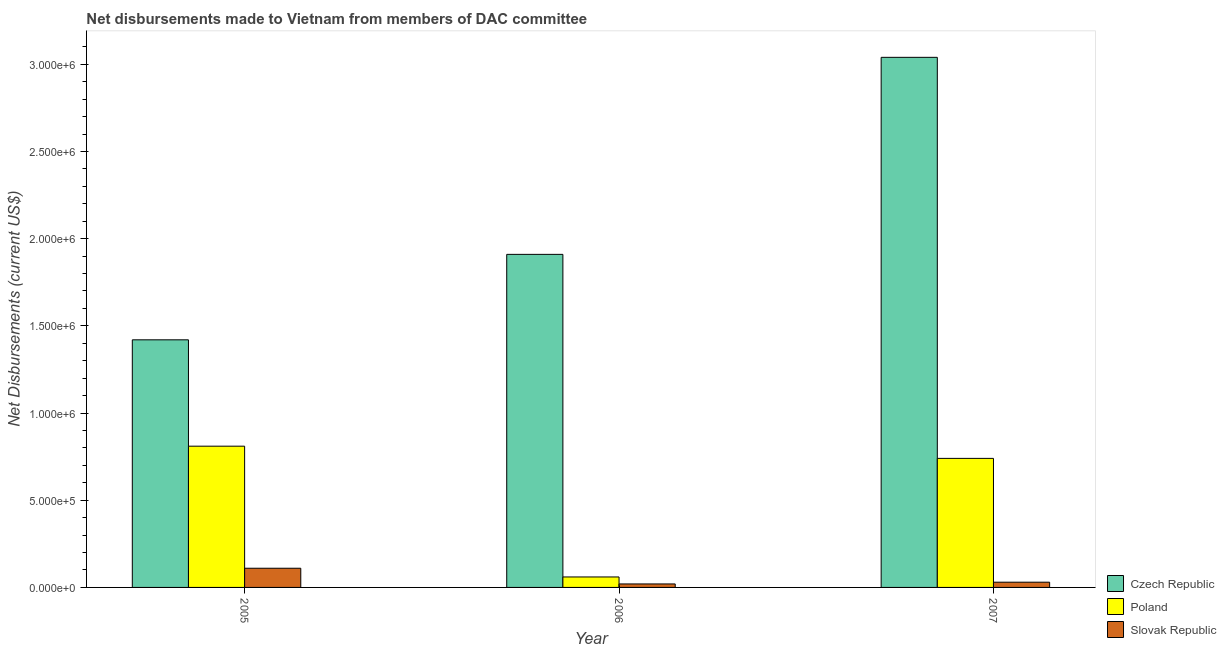How many groups of bars are there?
Make the answer very short. 3. Are the number of bars per tick equal to the number of legend labels?
Make the answer very short. Yes. Are the number of bars on each tick of the X-axis equal?
Offer a very short reply. Yes. How many bars are there on the 1st tick from the left?
Your answer should be compact. 3. How many bars are there on the 3rd tick from the right?
Make the answer very short. 3. What is the label of the 1st group of bars from the left?
Ensure brevity in your answer.  2005. In how many cases, is the number of bars for a given year not equal to the number of legend labels?
Ensure brevity in your answer.  0. What is the net disbursements made by slovak republic in 2006?
Give a very brief answer. 2.00e+04. Across all years, what is the maximum net disbursements made by slovak republic?
Provide a succinct answer. 1.10e+05. Across all years, what is the minimum net disbursements made by czech republic?
Ensure brevity in your answer.  1.42e+06. In which year was the net disbursements made by czech republic maximum?
Offer a very short reply. 2007. What is the total net disbursements made by czech republic in the graph?
Provide a short and direct response. 6.37e+06. What is the difference between the net disbursements made by czech republic in 2005 and that in 2007?
Offer a terse response. -1.62e+06. What is the difference between the net disbursements made by slovak republic in 2007 and the net disbursements made by poland in 2005?
Give a very brief answer. -8.00e+04. What is the average net disbursements made by poland per year?
Provide a succinct answer. 5.37e+05. What is the ratio of the net disbursements made by poland in 2006 to that in 2007?
Give a very brief answer. 0.08. Is the difference between the net disbursements made by poland in 2006 and 2007 greater than the difference between the net disbursements made by slovak republic in 2006 and 2007?
Provide a short and direct response. No. What is the difference between the highest and the lowest net disbursements made by czech republic?
Your response must be concise. 1.62e+06. In how many years, is the net disbursements made by czech republic greater than the average net disbursements made by czech republic taken over all years?
Your answer should be compact. 1. Is the sum of the net disbursements made by poland in 2006 and 2007 greater than the maximum net disbursements made by czech republic across all years?
Ensure brevity in your answer.  No. What does the 3rd bar from the left in 2007 represents?
Provide a succinct answer. Slovak Republic. What does the 1st bar from the right in 2005 represents?
Ensure brevity in your answer.  Slovak Republic. How many bars are there?
Your answer should be very brief. 9. Does the graph contain any zero values?
Provide a succinct answer. No. Where does the legend appear in the graph?
Provide a succinct answer. Bottom right. How are the legend labels stacked?
Your answer should be very brief. Vertical. What is the title of the graph?
Provide a short and direct response. Net disbursements made to Vietnam from members of DAC committee. Does "New Zealand" appear as one of the legend labels in the graph?
Offer a terse response. No. What is the label or title of the X-axis?
Offer a very short reply. Year. What is the label or title of the Y-axis?
Provide a succinct answer. Net Disbursements (current US$). What is the Net Disbursements (current US$) of Czech Republic in 2005?
Your answer should be very brief. 1.42e+06. What is the Net Disbursements (current US$) of Poland in 2005?
Your answer should be very brief. 8.10e+05. What is the Net Disbursements (current US$) of Czech Republic in 2006?
Offer a terse response. 1.91e+06. What is the Net Disbursements (current US$) in Slovak Republic in 2006?
Keep it short and to the point. 2.00e+04. What is the Net Disbursements (current US$) in Czech Republic in 2007?
Make the answer very short. 3.04e+06. What is the Net Disbursements (current US$) of Poland in 2007?
Give a very brief answer. 7.40e+05. Across all years, what is the maximum Net Disbursements (current US$) in Czech Republic?
Your response must be concise. 3.04e+06. Across all years, what is the maximum Net Disbursements (current US$) in Poland?
Your answer should be compact. 8.10e+05. Across all years, what is the maximum Net Disbursements (current US$) in Slovak Republic?
Offer a very short reply. 1.10e+05. Across all years, what is the minimum Net Disbursements (current US$) of Czech Republic?
Make the answer very short. 1.42e+06. Across all years, what is the minimum Net Disbursements (current US$) in Poland?
Keep it short and to the point. 6.00e+04. Across all years, what is the minimum Net Disbursements (current US$) in Slovak Republic?
Your answer should be compact. 2.00e+04. What is the total Net Disbursements (current US$) of Czech Republic in the graph?
Your answer should be compact. 6.37e+06. What is the total Net Disbursements (current US$) of Poland in the graph?
Offer a very short reply. 1.61e+06. What is the difference between the Net Disbursements (current US$) in Czech Republic in 2005 and that in 2006?
Your answer should be very brief. -4.90e+05. What is the difference between the Net Disbursements (current US$) in Poland in 2005 and that in 2006?
Provide a succinct answer. 7.50e+05. What is the difference between the Net Disbursements (current US$) in Czech Republic in 2005 and that in 2007?
Ensure brevity in your answer.  -1.62e+06. What is the difference between the Net Disbursements (current US$) of Czech Republic in 2006 and that in 2007?
Your answer should be compact. -1.13e+06. What is the difference between the Net Disbursements (current US$) of Poland in 2006 and that in 2007?
Keep it short and to the point. -6.80e+05. What is the difference between the Net Disbursements (current US$) of Slovak Republic in 2006 and that in 2007?
Your answer should be very brief. -10000. What is the difference between the Net Disbursements (current US$) in Czech Republic in 2005 and the Net Disbursements (current US$) in Poland in 2006?
Your answer should be very brief. 1.36e+06. What is the difference between the Net Disbursements (current US$) in Czech Republic in 2005 and the Net Disbursements (current US$) in Slovak Republic in 2006?
Your answer should be very brief. 1.40e+06. What is the difference between the Net Disbursements (current US$) of Poland in 2005 and the Net Disbursements (current US$) of Slovak Republic in 2006?
Provide a succinct answer. 7.90e+05. What is the difference between the Net Disbursements (current US$) in Czech Republic in 2005 and the Net Disbursements (current US$) in Poland in 2007?
Ensure brevity in your answer.  6.80e+05. What is the difference between the Net Disbursements (current US$) in Czech Republic in 2005 and the Net Disbursements (current US$) in Slovak Republic in 2007?
Keep it short and to the point. 1.39e+06. What is the difference between the Net Disbursements (current US$) in Poland in 2005 and the Net Disbursements (current US$) in Slovak Republic in 2007?
Your response must be concise. 7.80e+05. What is the difference between the Net Disbursements (current US$) of Czech Republic in 2006 and the Net Disbursements (current US$) of Poland in 2007?
Your answer should be compact. 1.17e+06. What is the difference between the Net Disbursements (current US$) in Czech Republic in 2006 and the Net Disbursements (current US$) in Slovak Republic in 2007?
Ensure brevity in your answer.  1.88e+06. What is the difference between the Net Disbursements (current US$) in Poland in 2006 and the Net Disbursements (current US$) in Slovak Republic in 2007?
Your answer should be very brief. 3.00e+04. What is the average Net Disbursements (current US$) of Czech Republic per year?
Your answer should be compact. 2.12e+06. What is the average Net Disbursements (current US$) of Poland per year?
Offer a terse response. 5.37e+05. What is the average Net Disbursements (current US$) in Slovak Republic per year?
Your answer should be compact. 5.33e+04. In the year 2005, what is the difference between the Net Disbursements (current US$) in Czech Republic and Net Disbursements (current US$) in Slovak Republic?
Offer a very short reply. 1.31e+06. In the year 2005, what is the difference between the Net Disbursements (current US$) in Poland and Net Disbursements (current US$) in Slovak Republic?
Provide a succinct answer. 7.00e+05. In the year 2006, what is the difference between the Net Disbursements (current US$) of Czech Republic and Net Disbursements (current US$) of Poland?
Provide a short and direct response. 1.85e+06. In the year 2006, what is the difference between the Net Disbursements (current US$) in Czech Republic and Net Disbursements (current US$) in Slovak Republic?
Your answer should be compact. 1.89e+06. In the year 2006, what is the difference between the Net Disbursements (current US$) of Poland and Net Disbursements (current US$) of Slovak Republic?
Your response must be concise. 4.00e+04. In the year 2007, what is the difference between the Net Disbursements (current US$) of Czech Republic and Net Disbursements (current US$) of Poland?
Offer a terse response. 2.30e+06. In the year 2007, what is the difference between the Net Disbursements (current US$) of Czech Republic and Net Disbursements (current US$) of Slovak Republic?
Your answer should be very brief. 3.01e+06. In the year 2007, what is the difference between the Net Disbursements (current US$) of Poland and Net Disbursements (current US$) of Slovak Republic?
Offer a terse response. 7.10e+05. What is the ratio of the Net Disbursements (current US$) in Czech Republic in 2005 to that in 2006?
Offer a very short reply. 0.74. What is the ratio of the Net Disbursements (current US$) in Slovak Republic in 2005 to that in 2006?
Provide a succinct answer. 5.5. What is the ratio of the Net Disbursements (current US$) in Czech Republic in 2005 to that in 2007?
Provide a succinct answer. 0.47. What is the ratio of the Net Disbursements (current US$) in Poland in 2005 to that in 2007?
Offer a terse response. 1.09. What is the ratio of the Net Disbursements (current US$) of Slovak Republic in 2005 to that in 2007?
Make the answer very short. 3.67. What is the ratio of the Net Disbursements (current US$) in Czech Republic in 2006 to that in 2007?
Your response must be concise. 0.63. What is the ratio of the Net Disbursements (current US$) of Poland in 2006 to that in 2007?
Give a very brief answer. 0.08. What is the ratio of the Net Disbursements (current US$) in Slovak Republic in 2006 to that in 2007?
Offer a very short reply. 0.67. What is the difference between the highest and the second highest Net Disbursements (current US$) of Czech Republic?
Your answer should be compact. 1.13e+06. What is the difference between the highest and the second highest Net Disbursements (current US$) of Slovak Republic?
Ensure brevity in your answer.  8.00e+04. What is the difference between the highest and the lowest Net Disbursements (current US$) in Czech Republic?
Give a very brief answer. 1.62e+06. What is the difference between the highest and the lowest Net Disbursements (current US$) in Poland?
Provide a short and direct response. 7.50e+05. What is the difference between the highest and the lowest Net Disbursements (current US$) in Slovak Republic?
Keep it short and to the point. 9.00e+04. 